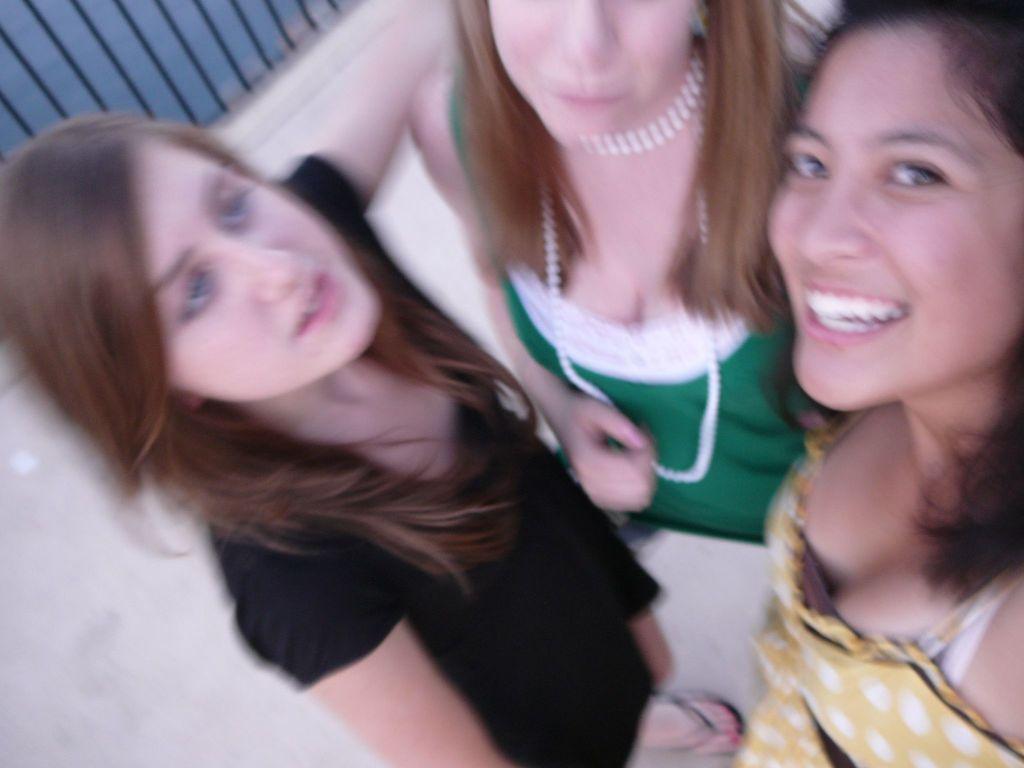Can you describe this image briefly? In this picture we can see three women,one woman is smiling and in the background we can see a fence. 